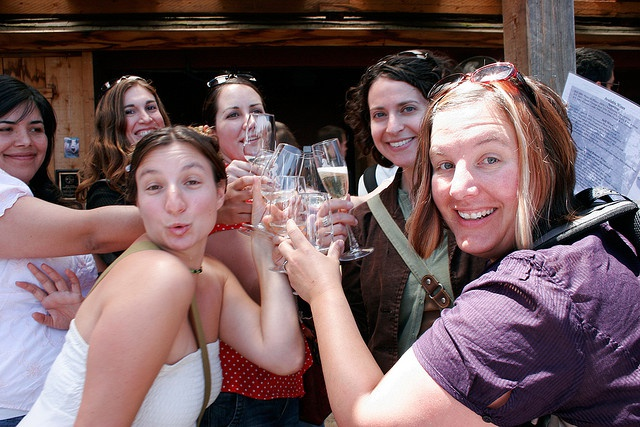Describe the objects in this image and their specific colors. I can see people in black, lightgray, lightpink, and brown tones, people in black, lightpink, darkgray, brown, and lavender tones, people in black, brown, lavender, and darkgray tones, people in black, darkgray, gray, and brown tones, and people in black, maroon, brown, and darkgray tones in this image. 